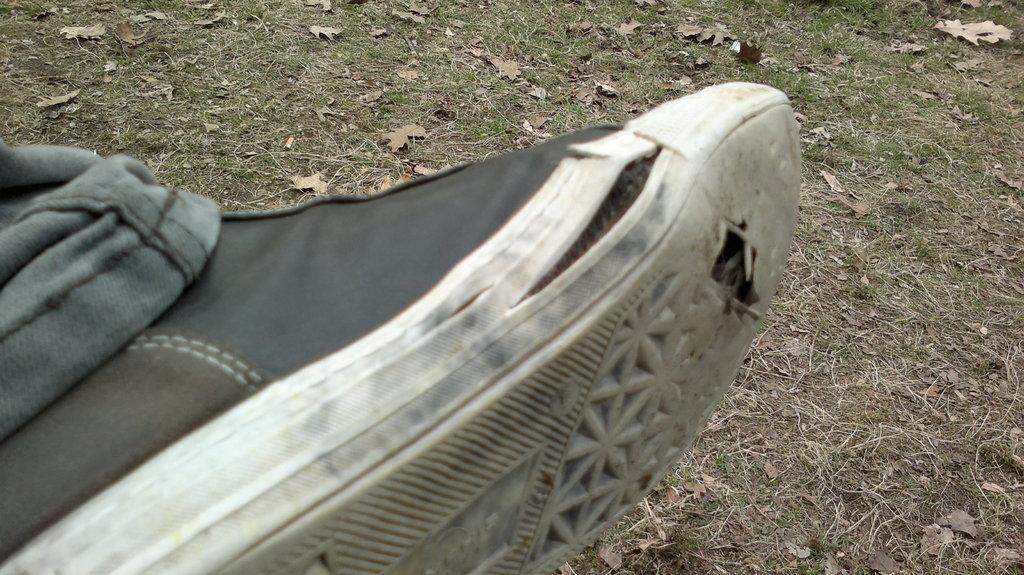Can you describe this image briefly? In this image I can see a person leg which is wearing a show on the left side. 